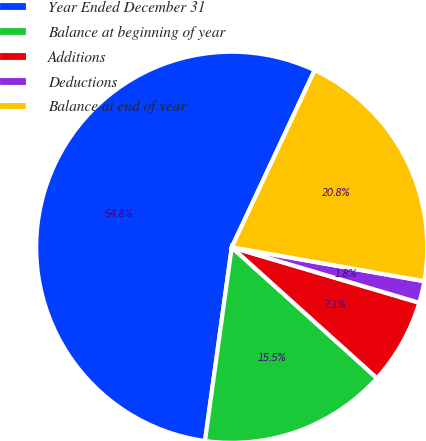Convert chart to OTSL. <chart><loc_0><loc_0><loc_500><loc_500><pie_chart><fcel>Year Ended December 31<fcel>Balance at beginning of year<fcel>Additions<fcel>Deductions<fcel>Balance at end of year<nl><fcel>54.78%<fcel>15.51%<fcel>7.1%<fcel>1.8%<fcel>20.81%<nl></chart> 